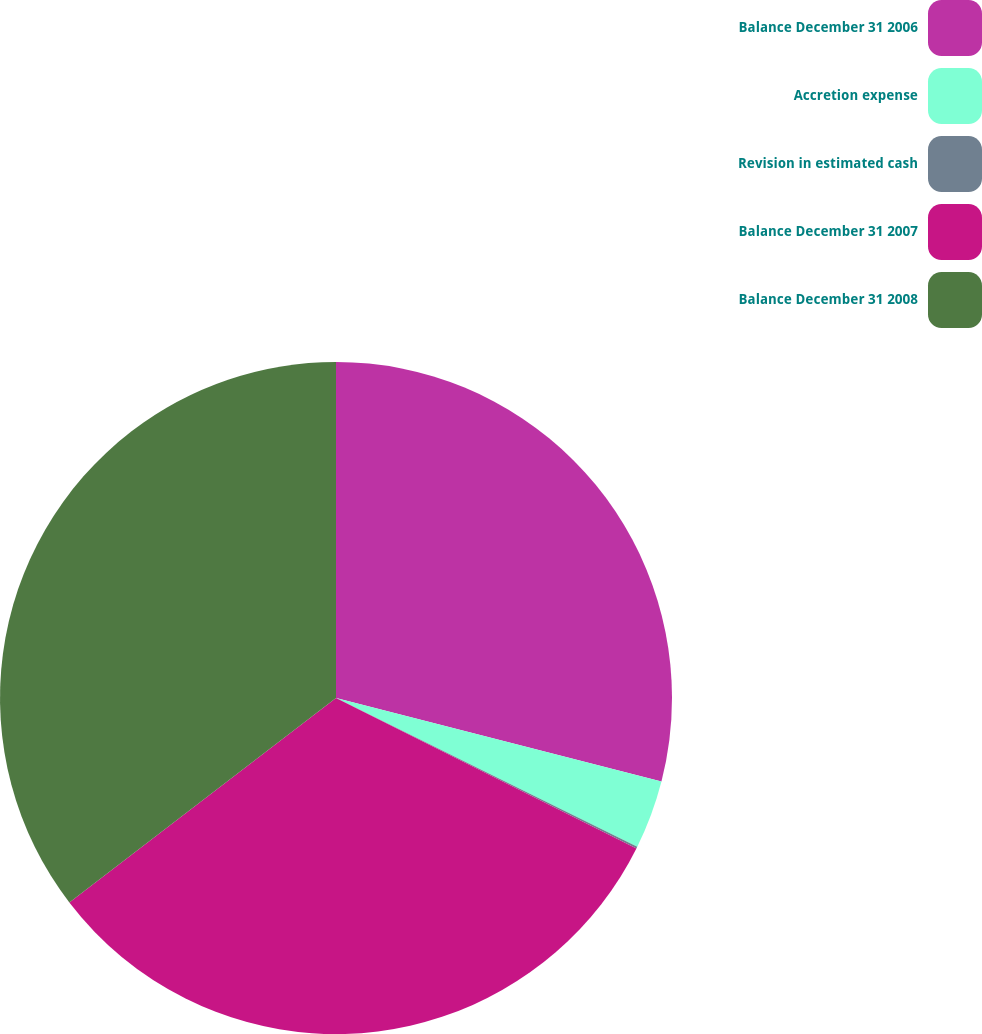Convert chart. <chart><loc_0><loc_0><loc_500><loc_500><pie_chart><fcel>Balance December 31 2006<fcel>Accretion expense<fcel>Revision in estimated cash<fcel>Balance December 31 2007<fcel>Balance December 31 2008<nl><fcel>29.0%<fcel>3.3%<fcel>0.09%<fcel>32.2%<fcel>35.41%<nl></chart> 